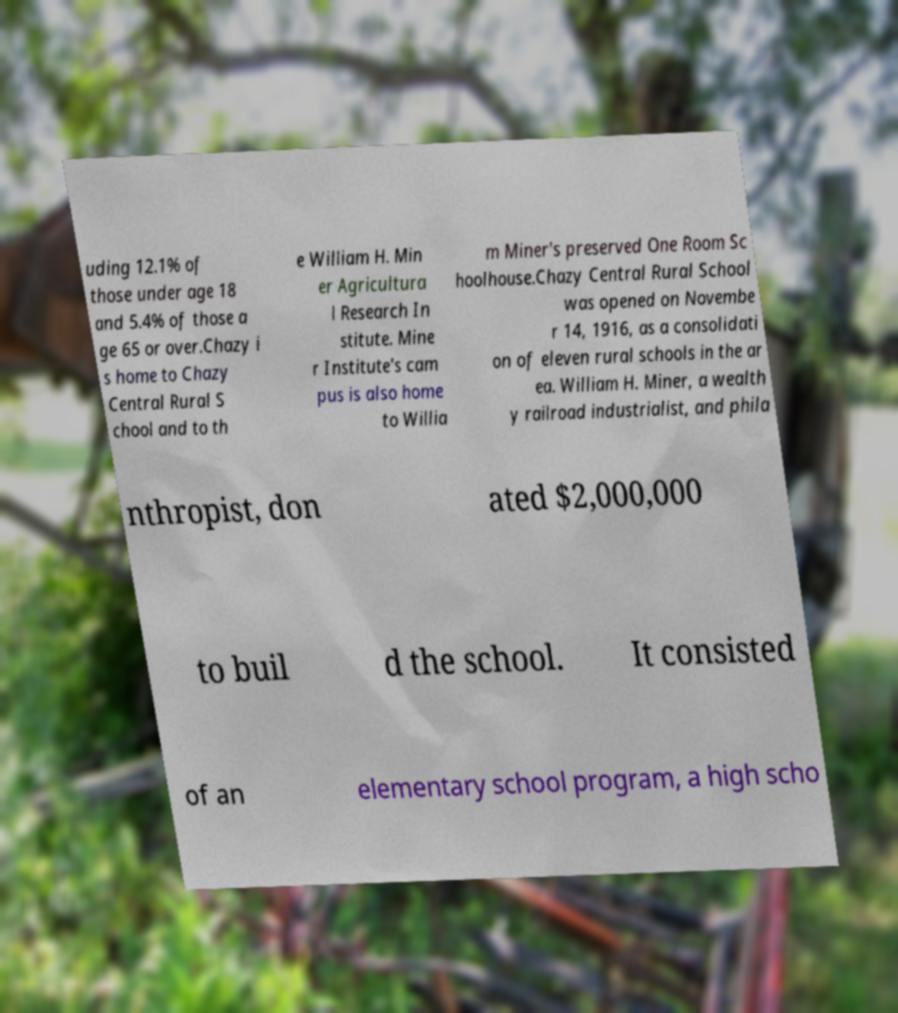There's text embedded in this image that I need extracted. Can you transcribe it verbatim? uding 12.1% of those under age 18 and 5.4% of those a ge 65 or over.Chazy i s home to Chazy Central Rural S chool and to th e William H. Min er Agricultura l Research In stitute. Mine r Institute's cam pus is also home to Willia m Miner's preserved One Room Sc hoolhouse.Chazy Central Rural School was opened on Novembe r 14, 1916, as a consolidati on of eleven rural schools in the ar ea. William H. Miner, a wealth y railroad industrialist, and phila nthropist, don ated $2,000,000 to buil d the school. It consisted of an elementary school program, a high scho 